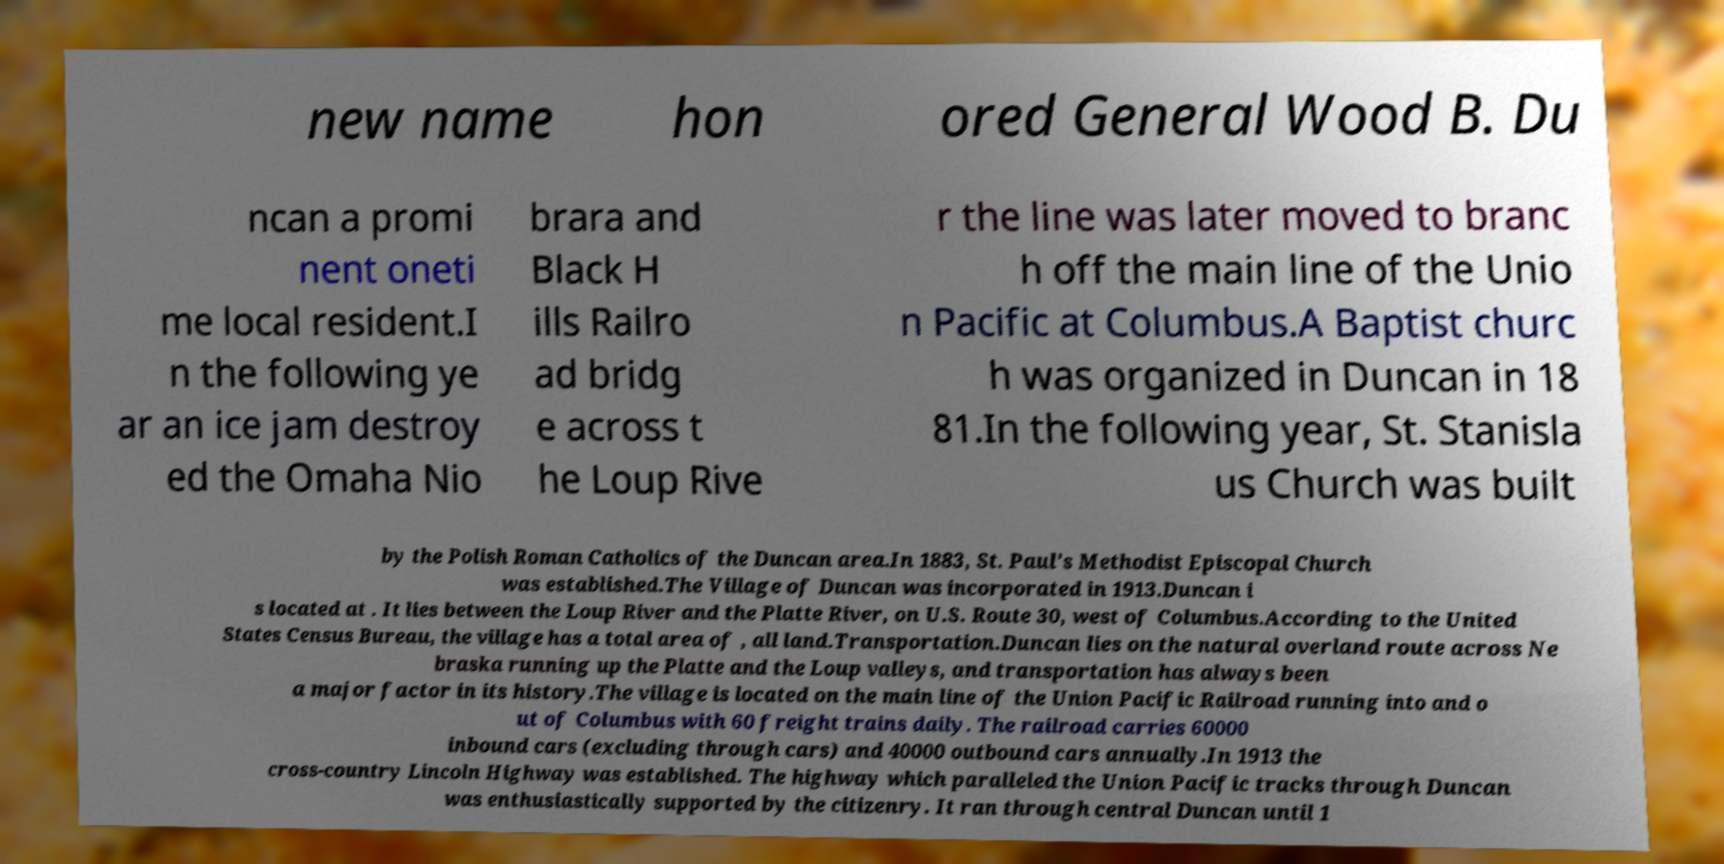Please identify and transcribe the text found in this image. new name hon ored General Wood B. Du ncan a promi nent oneti me local resident.I n the following ye ar an ice jam destroy ed the Omaha Nio brara and Black H ills Railro ad bridg e across t he Loup Rive r the line was later moved to branc h off the main line of the Unio n Pacific at Columbus.A Baptist churc h was organized in Duncan in 18 81.In the following year, St. Stanisla us Church was built by the Polish Roman Catholics of the Duncan area.In 1883, St. Paul's Methodist Episcopal Church was established.The Village of Duncan was incorporated in 1913.Duncan i s located at . It lies between the Loup River and the Platte River, on U.S. Route 30, west of Columbus.According to the United States Census Bureau, the village has a total area of , all land.Transportation.Duncan lies on the natural overland route across Ne braska running up the Platte and the Loup valleys, and transportation has always been a major factor in its history.The village is located on the main line of the Union Pacific Railroad running into and o ut of Columbus with 60 freight trains daily. The railroad carries 60000 inbound cars (excluding through cars) and 40000 outbound cars annually.In 1913 the cross-country Lincoln Highway was established. The highway which paralleled the Union Pacific tracks through Duncan was enthusiastically supported by the citizenry. It ran through central Duncan until 1 